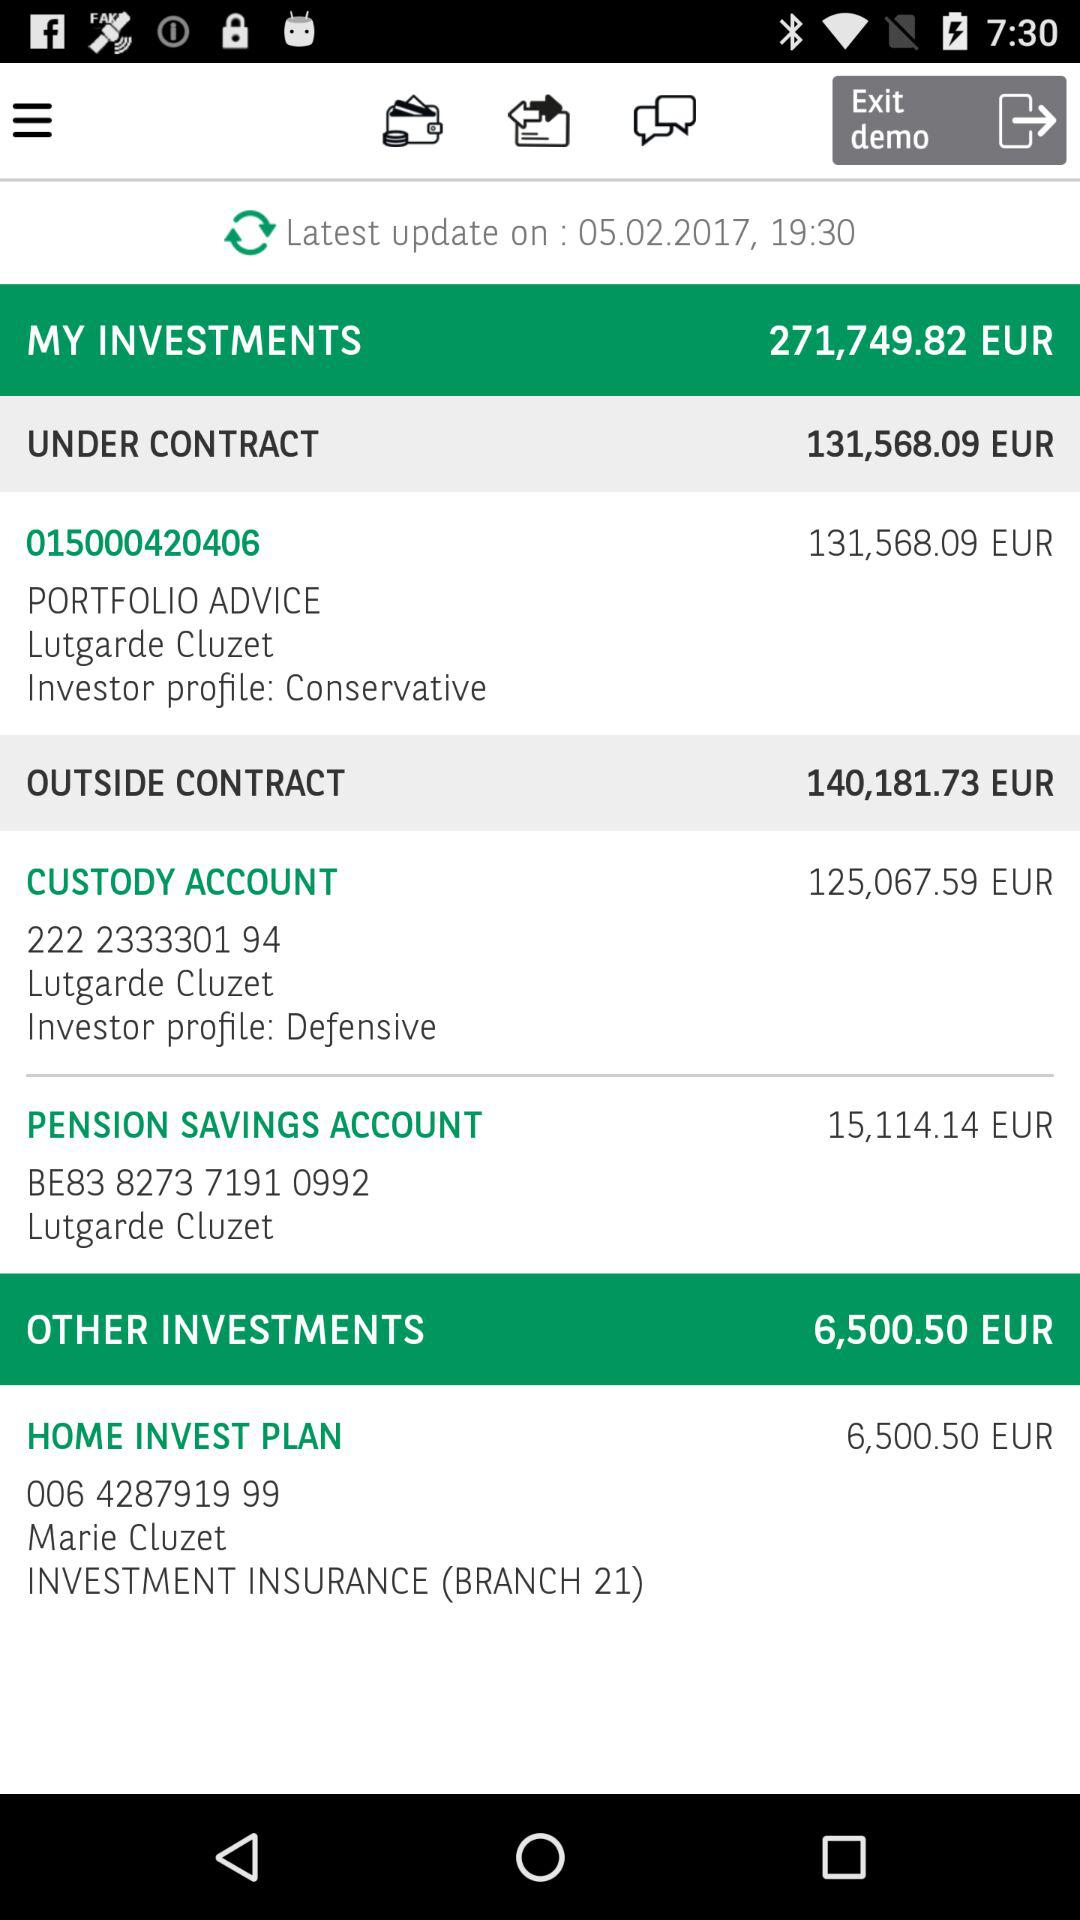When was it last updated? It was last updated on May 2, 2017. 